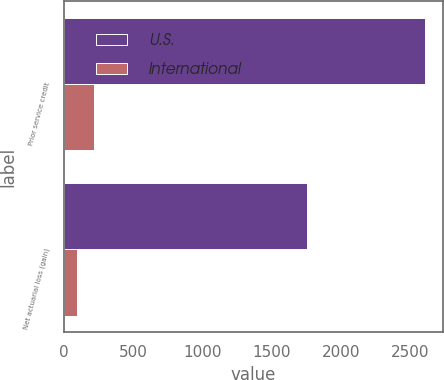<chart> <loc_0><loc_0><loc_500><loc_500><stacked_bar_chart><ecel><fcel>Prior service credit<fcel>Net actuarial loss (gain)<nl><fcel>U.S.<fcel>2608<fcel>1759<nl><fcel>International<fcel>218<fcel>96<nl></chart> 